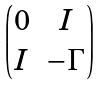<formula> <loc_0><loc_0><loc_500><loc_500>\begin{pmatrix} 0 & I \\ I & - \Gamma \end{pmatrix}</formula> 